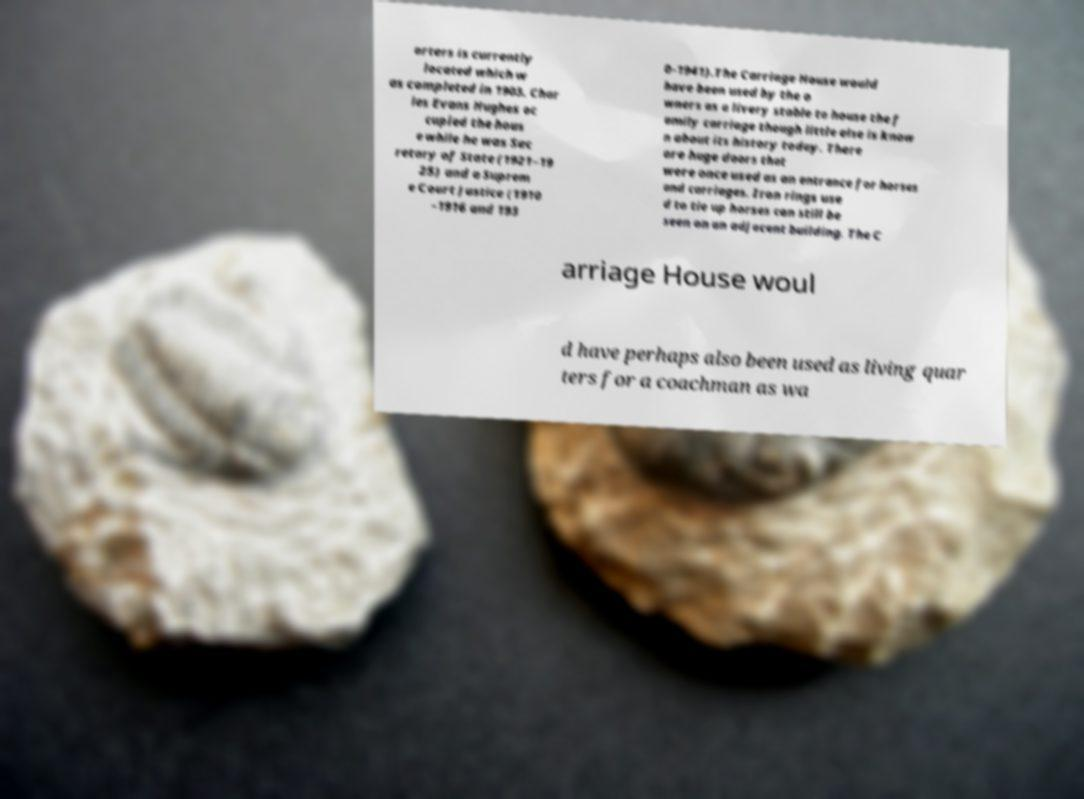Could you assist in decoding the text presented in this image and type it out clearly? arters is currently located which w as completed in 1903. Char les Evans Hughes oc cupied the hous e while he was Sec retary of State (1921–19 25) and a Suprem e Court Justice (1910 –1916 and 193 0–1941).The Carriage House would have been used by the o wners as a livery stable to house the f amily carriage though little else is know n about its history today. There are huge doors that were once used as an entrance for horses and carriages. Iron rings use d to tie up horses can still be seen on an adjacent building. The C arriage House woul d have perhaps also been used as living quar ters for a coachman as wa 